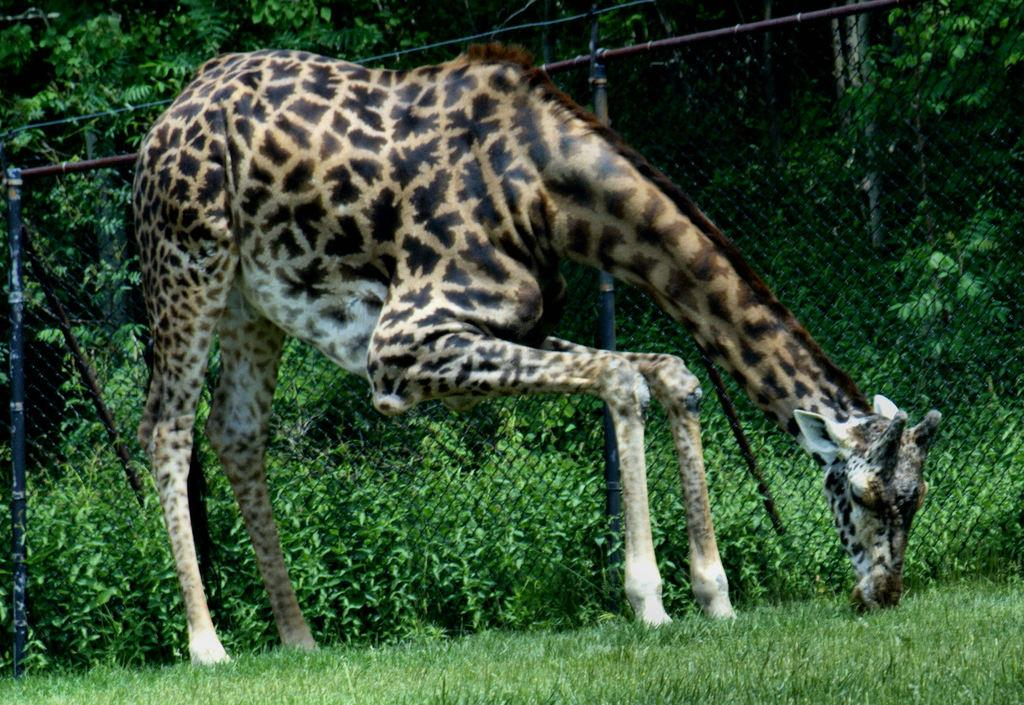What animal is the main subject of the image? There is a giraffe in the image. What is the giraffe doing in the image? The giraffe is eating grass. What can be seen behind the giraffe in the image? There are plants and trees visible behind a mesh. What rule is the giraffe following in the image? There is no specific rule mentioned or depicted in the image; the giraffe is simply eating grass. How many chickens are present in the image? There are no chickens present in the image; it features a giraffe eating grass and a background with plants, trees, and a mesh. 